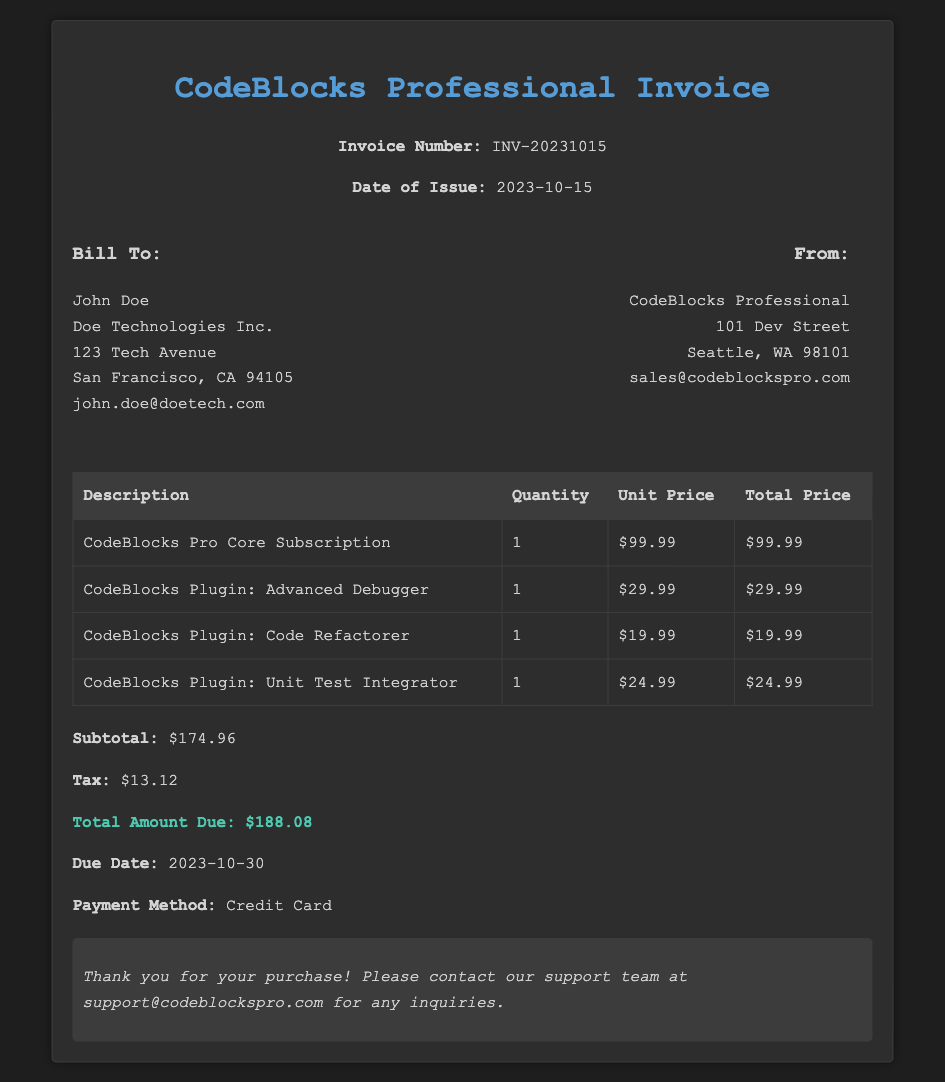What is the invoice number? The invoice number is listed prominently in the header section of the document.
Answer: INV-20231015 When was the invoice issued? The date of issue is clearly stated in the header section of the document.
Answer: 2023-10-15 Who is the recipient of the invoice? The recipient's information is provided under the "Bill To" section.
Answer: John Doe What is the subtotal amount? The subtotal is specified in the payment details section as part of the pricing breakdown.
Answer: $174.96 What is the total amount due? The total amount due is highlighted at the bottom of the payment details section.
Answer: $188.08 How many plugins are listed in the invoice? The invoice includes a list of plugins under the subscription details.
Answer: 3 What is the due date for the invoice? The due date is indicated in the payment details section.
Answer: 2023-10-30 What payment method was used? The payment method is mentioned in the payment details section.
Answer: Credit Card What is the quantity for the CodeBlocks Pro Core Subscription? The quantity is provided in the subscription details table.
Answer: 1 